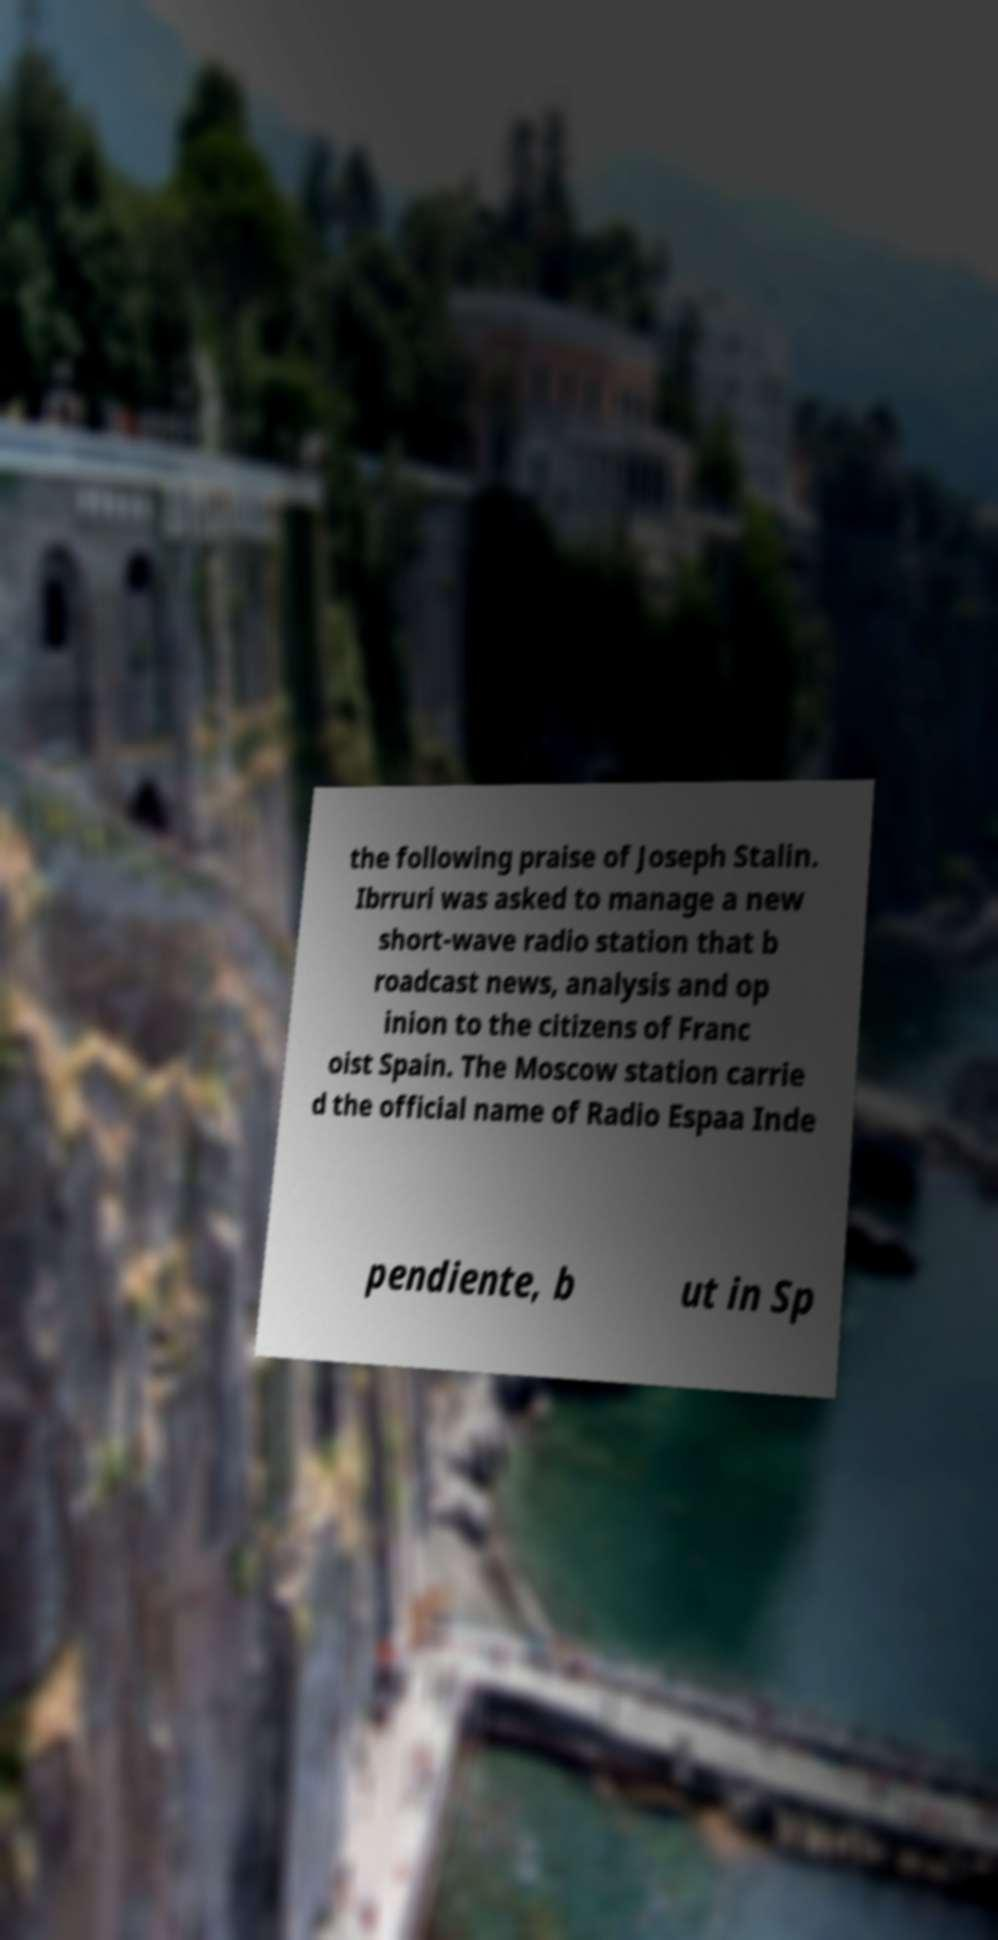For documentation purposes, I need the text within this image transcribed. Could you provide that? the following praise of Joseph Stalin. Ibrruri was asked to manage a new short-wave radio station that b roadcast news, analysis and op inion to the citizens of Franc oist Spain. The Moscow station carrie d the official name of Radio Espaa Inde pendiente, b ut in Sp 